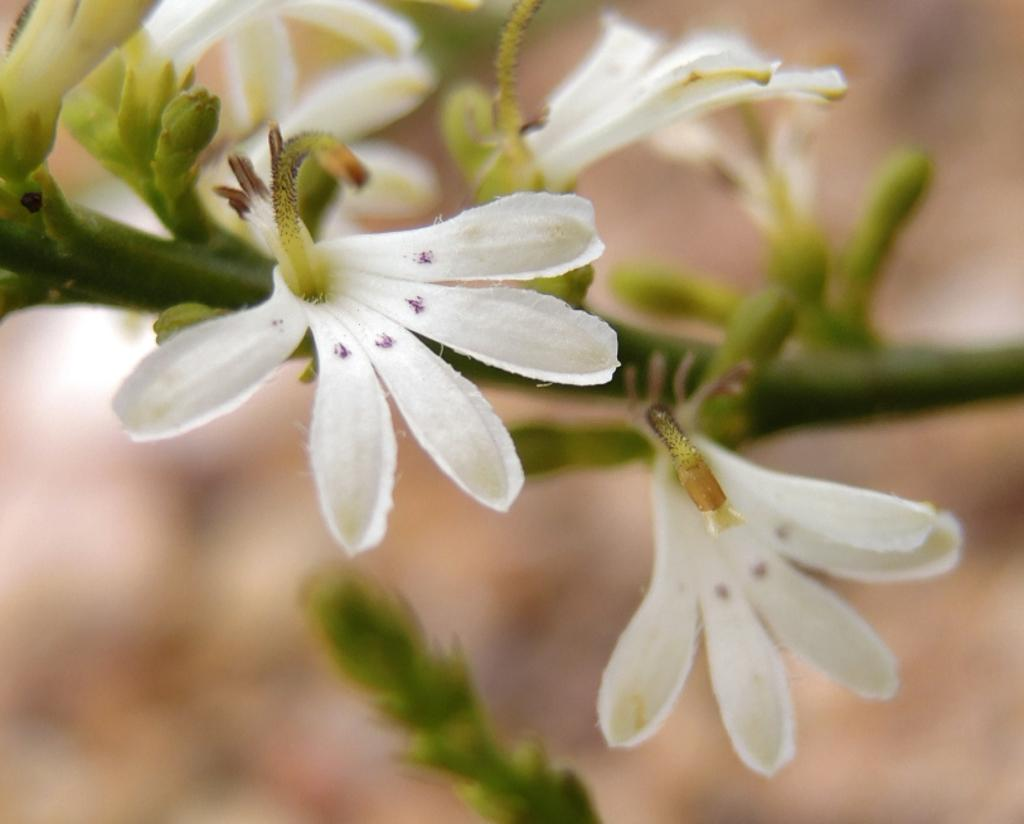What is the main subject of the image? The main subject of the image is a stem with flowers. Can you describe the flowers on the stem? There are buds on the stem. What can be observed about the background of the image? The background of the image is blurry. What type of alarm can be heard going off in the image? There is no alarm present in the image; it is a photograph of a stem with flowers and buds. Can you tell me how many fingers are visible in the image? There are no fingers visible in the image. 